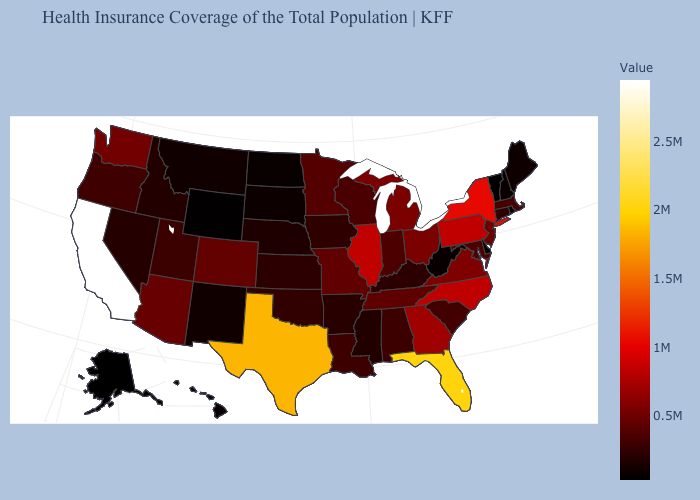Among the states that border Washington , which have the lowest value?
Short answer required. Idaho. 